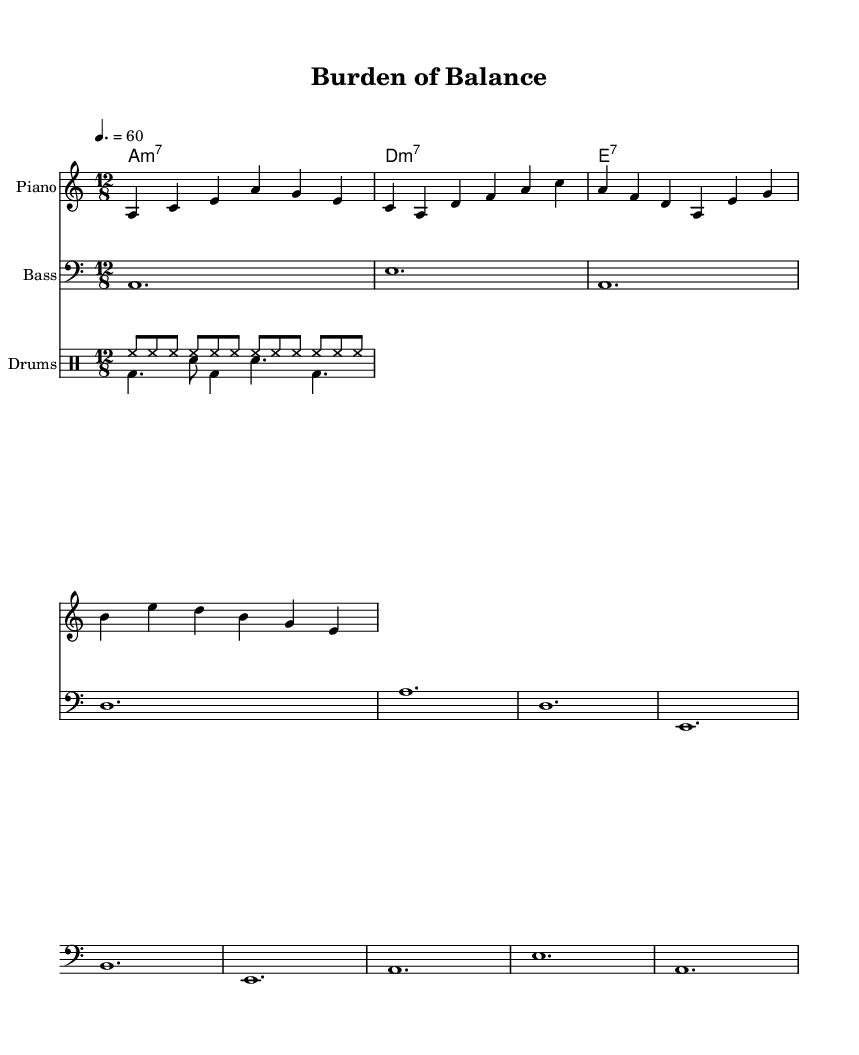What is the key signature of this music? The key signature is A minor, which has no sharps or flats. This is identified by looking at the clef and the absence of any sharps or flats in the key signature line.
Answer: A minor What is the time signature of this music? The time signature is 12/8, which is indicated at the beginning of the sheet music. The notation shows there are 12 eighth notes per measure, leading to the characteristic flow of blues music.
Answer: 12/8 What is the tempo marking? The tempo marking is 60 beats per minute (BPM), denoted by the text "4. = 60" above the staff. This indicates a slow pace typical of a blues song.
Answer: 60 How many measures are in the melody? The melody consists of 6 measures, which can be determined by counting the bar lines visible in the staff. Each separation between bars indicates a new measure.
Answer: 6 What type of chords are used in the harmonies? The harmonies consist of minor 7th and dominant 7th chords, as indicated by the notations "m7" for the minor 7th chords and "7" for the dominant 7th chord. This is typical for blues music, which often features these chord types.
Answer: Minor 7th and Dominant 7th What is the primary theme reflected in the melody? The primary theme reflects feelings of balancing multiple responsibilities, which can be inferred from the slow, soulful nature of the melody and the overall blues genre, which often communicates emotional struggles.
Answer: Balancing responsibilities What instruments are featured in this score? The instruments featured are Piano, Bass, and Drums, indicated by the respective staff titles for each. This combination is commonly found in blues music settings.
Answer: Piano, Bass, Drums 